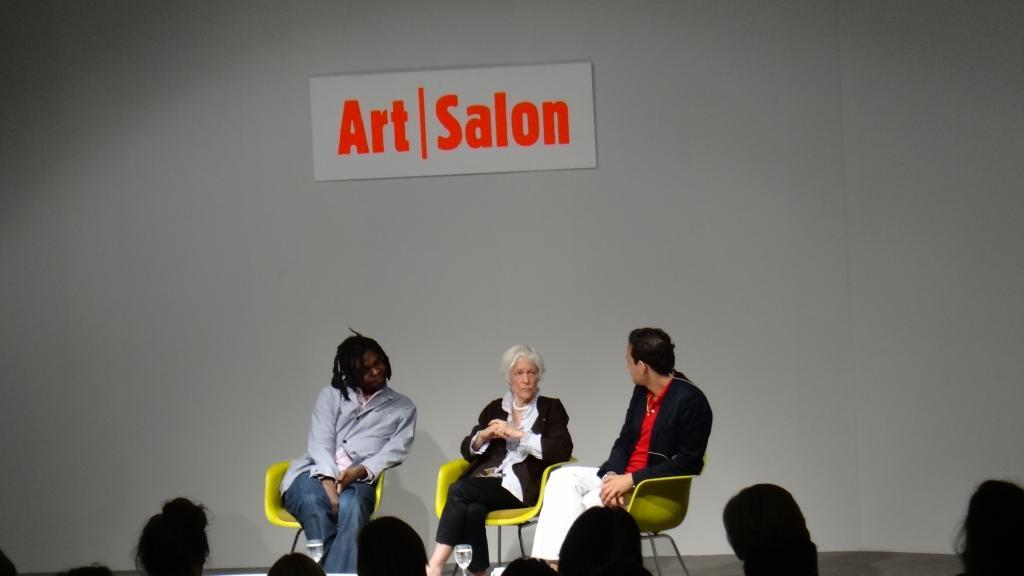How many people are in the image? There are three persons in the image. What are the persons doing in the image? The persons are sitting on chairs. What can be seen on the wall in the image? There is a board on the wall. Can you describe the persons' heads in the image? The persons' heads are visible in the image. What type of button is being used to hold the sheet in place in the image? There is no sheet or button present in the image; it features three persons sitting on chairs with a board on the wall. 